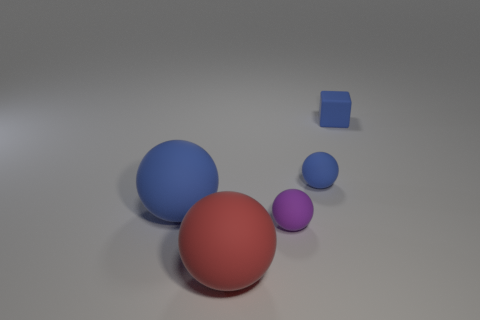Can you describe the sizes and colors of the objects in this image? Certainly! In the image, there are four spherical objects of varying sizes and colors. Starting from the largest, there is a big blue sphere, followed by a medium-sized red sphere, and then a smaller purple sphere. There's also a tiny blue cube on the far right.  What might these objects represent in an artistic context? In an artistic context, these objects could symbolize elements of diversity and unity — different sizes and colors coming together in one space. The varying forms and hues might also represent individuality or unique characteristics within a group. 